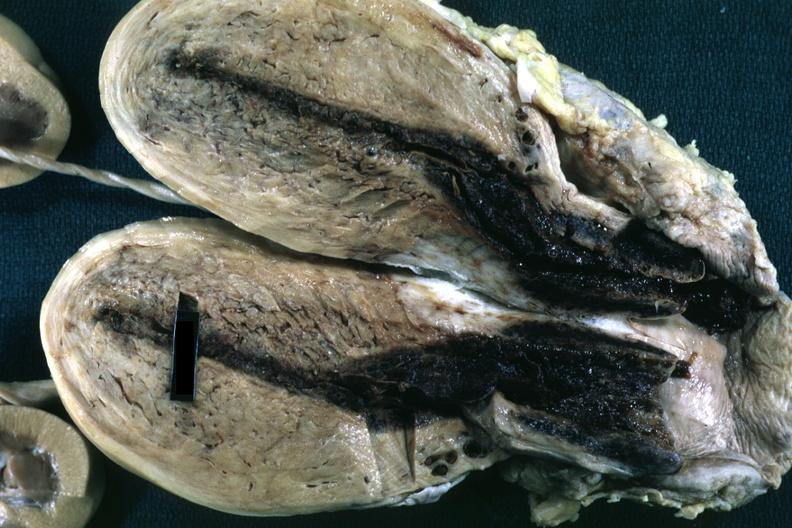s lymphangiomatosis present?
Answer the question using a single word or phrase. No 